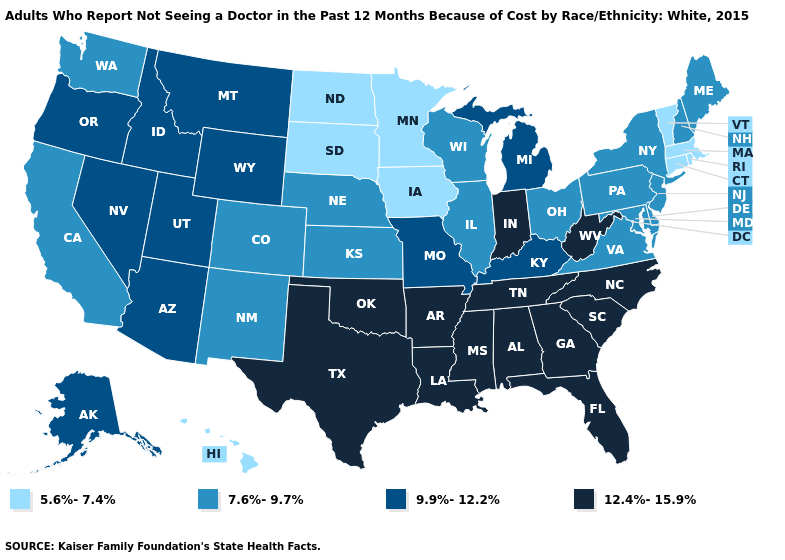Does Arkansas have the highest value in the USA?
Short answer required. Yes. Among the states that border Kentucky , does Tennessee have the lowest value?
Write a very short answer. No. Does Rhode Island have the lowest value in the Northeast?
Write a very short answer. Yes. What is the lowest value in states that border Oklahoma?
Short answer required. 7.6%-9.7%. Does Alaska have the lowest value in the USA?
Short answer required. No. Name the states that have a value in the range 9.9%-12.2%?
Concise answer only. Alaska, Arizona, Idaho, Kentucky, Michigan, Missouri, Montana, Nevada, Oregon, Utah, Wyoming. How many symbols are there in the legend?
Write a very short answer. 4. Does the map have missing data?
Answer briefly. No. What is the lowest value in the USA?
Be succinct. 5.6%-7.4%. Name the states that have a value in the range 12.4%-15.9%?
Write a very short answer. Alabama, Arkansas, Florida, Georgia, Indiana, Louisiana, Mississippi, North Carolina, Oklahoma, South Carolina, Tennessee, Texas, West Virginia. What is the value of Alaska?
Be succinct. 9.9%-12.2%. Name the states that have a value in the range 7.6%-9.7%?
Be succinct. California, Colorado, Delaware, Illinois, Kansas, Maine, Maryland, Nebraska, New Hampshire, New Jersey, New Mexico, New York, Ohio, Pennsylvania, Virginia, Washington, Wisconsin. What is the value of Colorado?
Concise answer only. 7.6%-9.7%. Does Vermont have a lower value than Louisiana?
Be succinct. Yes. 